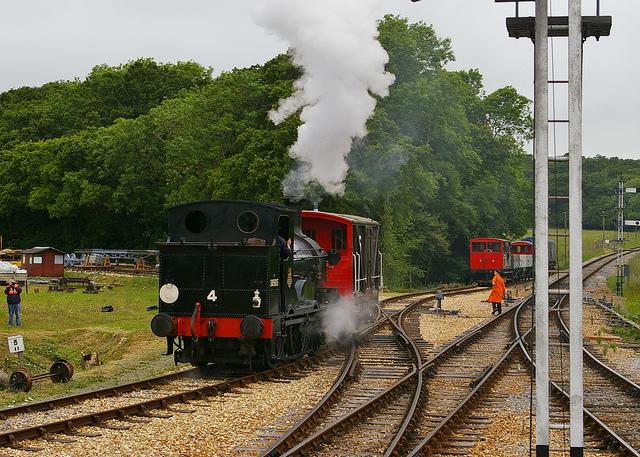What color clothes is the person on the right wearing?
Give a very brief answer. Orange. What type of train is this?
Give a very brief answer. Steam. What color are the trees?
Answer briefly. Green. What is the sum of the numbers on the trains?
Give a very brief answer. 4. 